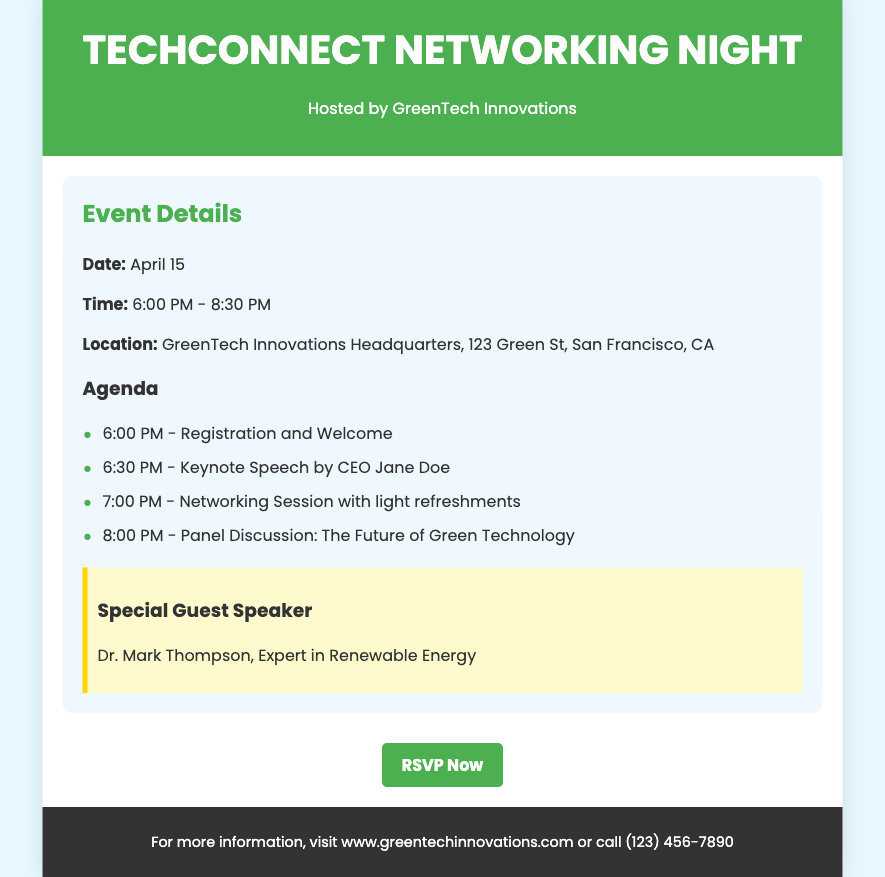What is the title of the event? The title of the event is mentioned prominently in the header of the document.
Answer: TechConnect Networking Night Who is hosting the event? The host of the event is indicated right below the title.
Answer: GreenTech Innovations What is the date of the event? The date is listed clearly in the event details section.
Answer: April 15 What time does the event start? The start time can be found in the event details section.
Answer: 6:00 PM Who is the special guest speaker? The special guest is specified in a separate section for emphasis.
Answer: Dr. Mark Thompson What type of event is being held? The nature of the event is evident from the title and the content.
Answer: Networking Night How many agenda items are mentioned? The agenda section lists the scheduled events, from which we can count the items.
Answer: Four What will follow the keynote speech according to the agenda? The agenda provides a sequence of activities after the keynote speech.
Answer: Networking Session What is the location of the event? The location is outlined in the event details section.
Answer: GreenTech Innovations Headquarters, 123 Green St, San Francisco, CA What is the RSVP action for the event? The call to action is described towards the end of the content.
Answer: RSVP Now 